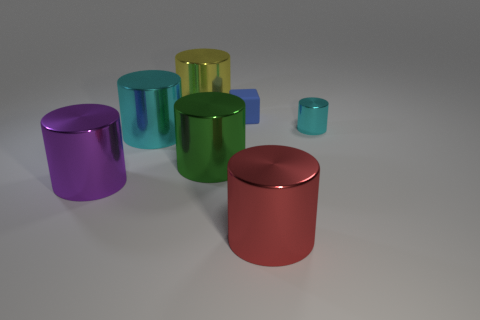Subtract all small cylinders. How many cylinders are left? 5 Add 1 tiny green shiny objects. How many objects exist? 8 Subtract 1 cubes. How many cubes are left? 0 Subtract all cylinders. How many objects are left? 1 Subtract all green cylinders. How many cylinders are left? 5 Subtract 0 cyan spheres. How many objects are left? 7 Subtract all purple blocks. Subtract all gray cylinders. How many blocks are left? 1 Subtract all red balls. How many brown cylinders are left? 0 Subtract all tiny cyan metallic blocks. Subtract all purple cylinders. How many objects are left? 6 Add 2 tiny blue rubber cubes. How many tiny blue rubber cubes are left? 3 